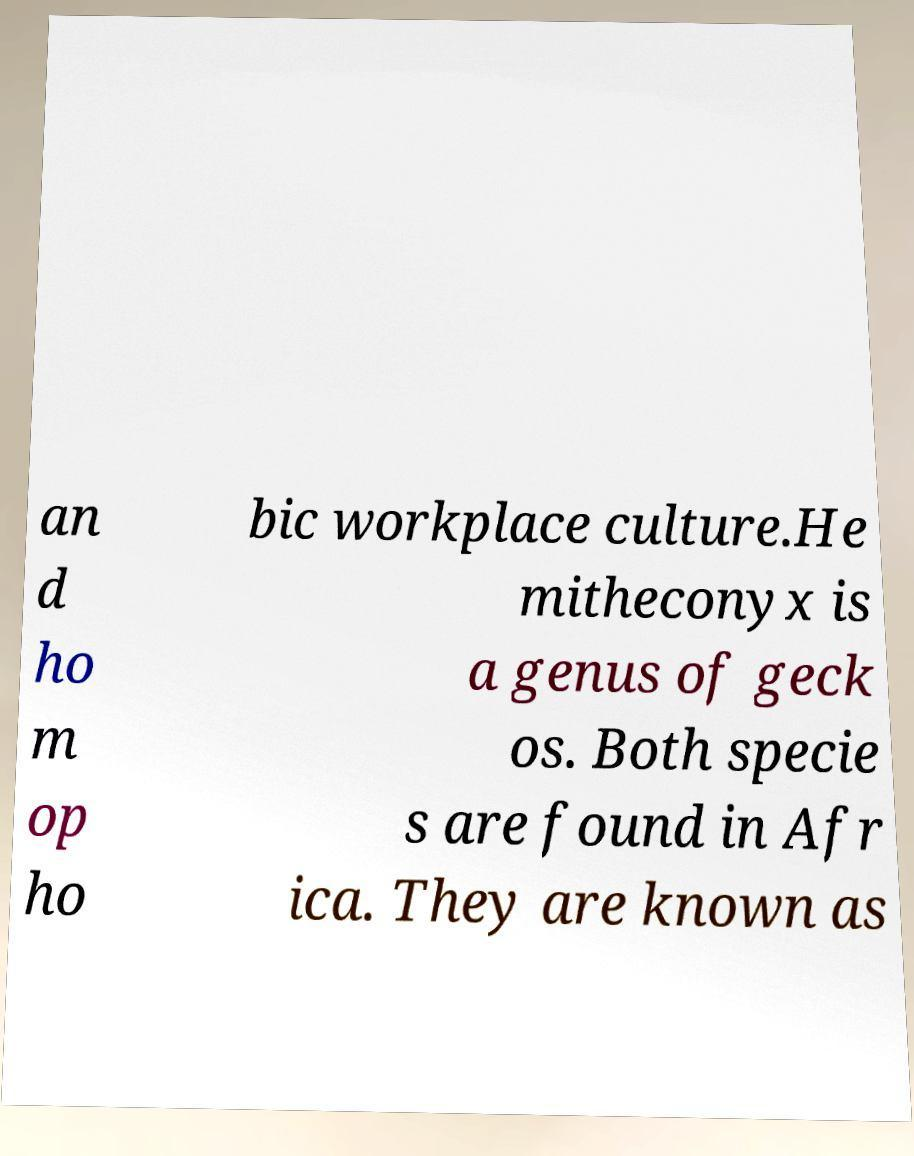What messages or text are displayed in this image? I need them in a readable, typed format. an d ho m op ho bic workplace culture.He mitheconyx is a genus of geck os. Both specie s are found in Afr ica. They are known as 